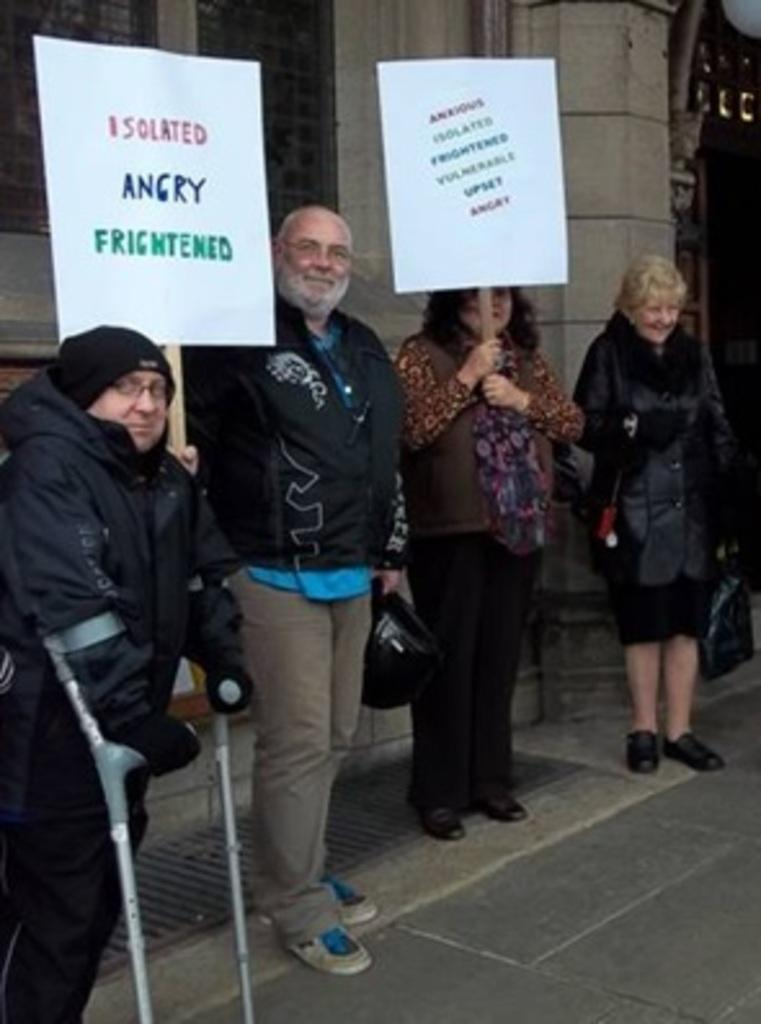Who is present in the image? There are people in the image. What are the people wearing? The people are wearing sweatshirts. Where are the people located in the image? The people are standing on the side of a road. What can be seen in the background of the image? There is a wall in the image. What are the people holding in the image? The people are holding banners with slogans on them. What language is spoken by the people in the image? The image does not provide any information about the language spoken by the people. How does the surprise appear in the image? There is no surprise present in the image. 